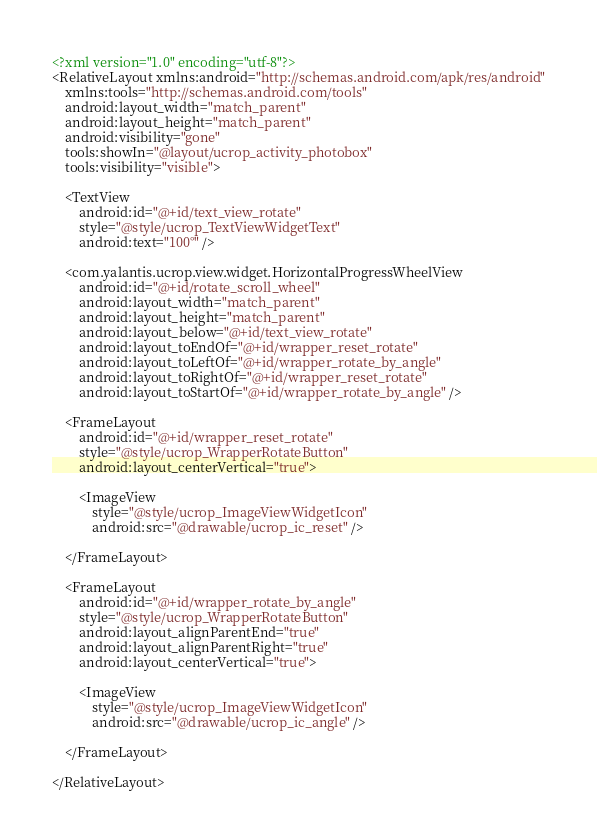<code> <loc_0><loc_0><loc_500><loc_500><_XML_><?xml version="1.0" encoding="utf-8"?>
<RelativeLayout xmlns:android="http://schemas.android.com/apk/res/android"
    xmlns:tools="http://schemas.android.com/tools"
    android:layout_width="match_parent"
    android:layout_height="match_parent"
    android:visibility="gone"
    tools:showIn="@layout/ucrop_activity_photobox"
    tools:visibility="visible">

    <TextView
        android:id="@+id/text_view_rotate"
        style="@style/ucrop_TextViewWidgetText"
        android:text="100°" />

    <com.yalantis.ucrop.view.widget.HorizontalProgressWheelView
        android:id="@+id/rotate_scroll_wheel"
        android:layout_width="match_parent"
        android:layout_height="match_parent"
        android:layout_below="@+id/text_view_rotate"
        android:layout_toEndOf="@+id/wrapper_reset_rotate"
        android:layout_toLeftOf="@+id/wrapper_rotate_by_angle"
        android:layout_toRightOf="@+id/wrapper_reset_rotate"
        android:layout_toStartOf="@+id/wrapper_rotate_by_angle" />

    <FrameLayout
        android:id="@+id/wrapper_reset_rotate"
        style="@style/ucrop_WrapperRotateButton"
        android:layout_centerVertical="true">

        <ImageView
            style="@style/ucrop_ImageViewWidgetIcon"
            android:src="@drawable/ucrop_ic_reset" />

    </FrameLayout>

    <FrameLayout
        android:id="@+id/wrapper_rotate_by_angle"
        style="@style/ucrop_WrapperRotateButton"
        android:layout_alignParentEnd="true"
        android:layout_alignParentRight="true"
        android:layout_centerVertical="true">

        <ImageView
            style="@style/ucrop_ImageViewWidgetIcon"
            android:src="@drawable/ucrop_ic_angle" />

    </FrameLayout>

</RelativeLayout></code> 